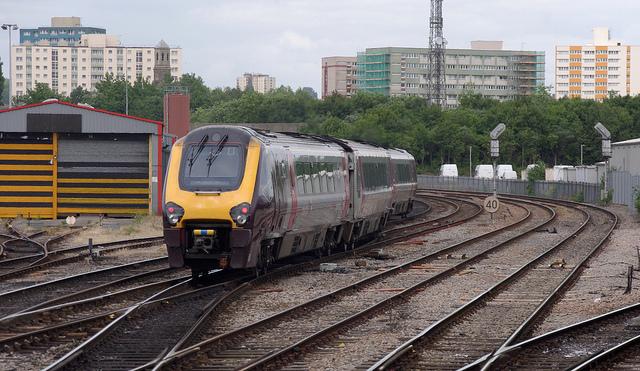Is there more than one track visible?
Write a very short answer. Yes. Where is the sign that says "40"?
Write a very short answer. Between tracks. How many cars do you see?
Be succinct. 3. Is this a freight train?
Quick response, please. No. 